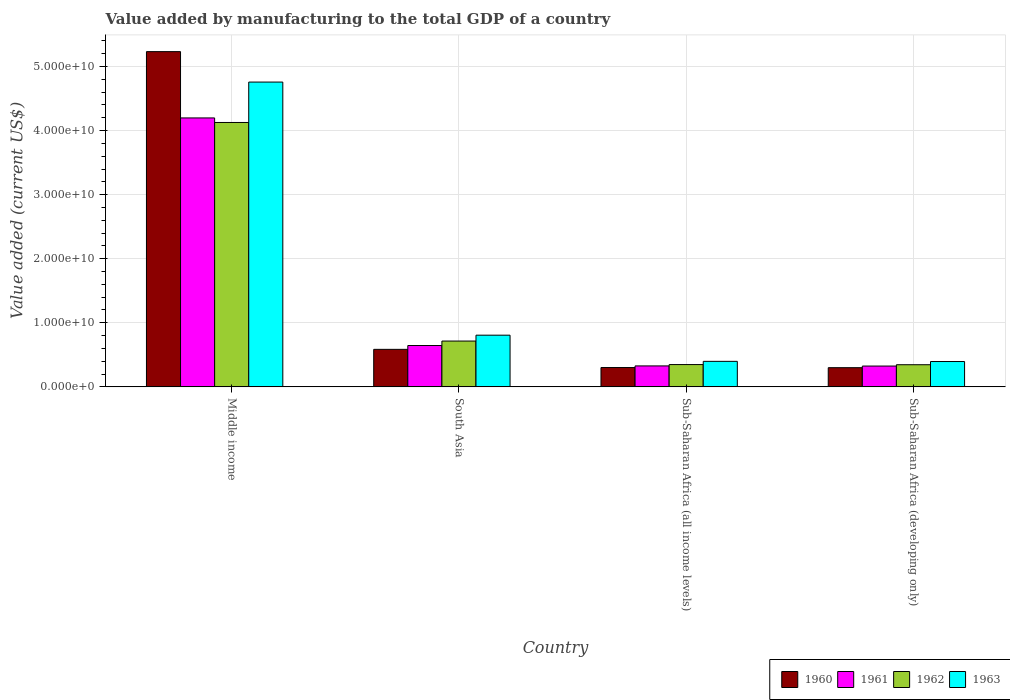Are the number of bars per tick equal to the number of legend labels?
Your answer should be compact. Yes. How many bars are there on the 4th tick from the left?
Give a very brief answer. 4. How many bars are there on the 3rd tick from the right?
Give a very brief answer. 4. What is the label of the 3rd group of bars from the left?
Provide a succinct answer. Sub-Saharan Africa (all income levels). In how many cases, is the number of bars for a given country not equal to the number of legend labels?
Your response must be concise. 0. What is the value added by manufacturing to the total GDP in 1960 in South Asia?
Offer a terse response. 5.86e+09. Across all countries, what is the maximum value added by manufacturing to the total GDP in 1963?
Your answer should be very brief. 4.76e+1. Across all countries, what is the minimum value added by manufacturing to the total GDP in 1963?
Offer a very short reply. 3.95e+09. In which country was the value added by manufacturing to the total GDP in 1963 minimum?
Offer a terse response. Sub-Saharan Africa (developing only). What is the total value added by manufacturing to the total GDP in 1961 in the graph?
Ensure brevity in your answer.  5.49e+1. What is the difference between the value added by manufacturing to the total GDP in 1961 in South Asia and that in Sub-Saharan Africa (all income levels)?
Keep it short and to the point. 3.18e+09. What is the difference between the value added by manufacturing to the total GDP in 1961 in South Asia and the value added by manufacturing to the total GDP in 1962 in Sub-Saharan Africa (all income levels)?
Your answer should be compact. 2.97e+09. What is the average value added by manufacturing to the total GDP in 1961 per country?
Offer a very short reply. 1.37e+1. What is the difference between the value added by manufacturing to the total GDP of/in 1963 and value added by manufacturing to the total GDP of/in 1961 in South Asia?
Your answer should be compact. 1.61e+09. In how many countries, is the value added by manufacturing to the total GDP in 1962 greater than 46000000000 US$?
Ensure brevity in your answer.  0. What is the ratio of the value added by manufacturing to the total GDP in 1962 in Sub-Saharan Africa (all income levels) to that in Sub-Saharan Africa (developing only)?
Offer a very short reply. 1.01. Is the value added by manufacturing to the total GDP in 1960 in Sub-Saharan Africa (all income levels) less than that in Sub-Saharan Africa (developing only)?
Ensure brevity in your answer.  No. Is the difference between the value added by manufacturing to the total GDP in 1963 in Sub-Saharan Africa (all income levels) and Sub-Saharan Africa (developing only) greater than the difference between the value added by manufacturing to the total GDP in 1961 in Sub-Saharan Africa (all income levels) and Sub-Saharan Africa (developing only)?
Your answer should be very brief. Yes. What is the difference between the highest and the second highest value added by manufacturing to the total GDP in 1960?
Provide a succinct answer. 2.84e+09. What is the difference between the highest and the lowest value added by manufacturing to the total GDP in 1963?
Keep it short and to the point. 4.36e+1. Is it the case that in every country, the sum of the value added by manufacturing to the total GDP in 1962 and value added by manufacturing to the total GDP in 1963 is greater than the sum of value added by manufacturing to the total GDP in 1961 and value added by manufacturing to the total GDP in 1960?
Your answer should be very brief. Yes. What does the 4th bar from the left in Sub-Saharan Africa (all income levels) represents?
Provide a succinct answer. 1963. What does the 3rd bar from the right in Sub-Saharan Africa (all income levels) represents?
Keep it short and to the point. 1961. How many bars are there?
Ensure brevity in your answer.  16. Are all the bars in the graph horizontal?
Offer a very short reply. No. How are the legend labels stacked?
Your answer should be very brief. Horizontal. What is the title of the graph?
Keep it short and to the point. Value added by manufacturing to the total GDP of a country. Does "1961" appear as one of the legend labels in the graph?
Your response must be concise. Yes. What is the label or title of the Y-axis?
Make the answer very short. Value added (current US$). What is the Value added (current US$) of 1960 in Middle income?
Your response must be concise. 5.23e+1. What is the Value added (current US$) of 1961 in Middle income?
Your answer should be compact. 4.20e+1. What is the Value added (current US$) in 1962 in Middle income?
Keep it short and to the point. 4.13e+1. What is the Value added (current US$) of 1963 in Middle income?
Keep it short and to the point. 4.76e+1. What is the Value added (current US$) in 1960 in South Asia?
Make the answer very short. 5.86e+09. What is the Value added (current US$) of 1961 in South Asia?
Give a very brief answer. 6.45e+09. What is the Value added (current US$) of 1962 in South Asia?
Offer a very short reply. 7.15e+09. What is the Value added (current US$) of 1963 in South Asia?
Your answer should be compact. 8.07e+09. What is the Value added (current US$) in 1960 in Sub-Saharan Africa (all income levels)?
Your answer should be very brief. 3.02e+09. What is the Value added (current US$) of 1961 in Sub-Saharan Africa (all income levels)?
Your answer should be compact. 3.27e+09. What is the Value added (current US$) in 1962 in Sub-Saharan Africa (all income levels)?
Make the answer very short. 3.48e+09. What is the Value added (current US$) of 1963 in Sub-Saharan Africa (all income levels)?
Offer a very short reply. 3.98e+09. What is the Value added (current US$) in 1960 in Sub-Saharan Africa (developing only)?
Provide a succinct answer. 2.99e+09. What is the Value added (current US$) of 1961 in Sub-Saharan Africa (developing only)?
Your response must be concise. 3.25e+09. What is the Value added (current US$) in 1962 in Sub-Saharan Africa (developing only)?
Your answer should be compact. 3.46e+09. What is the Value added (current US$) in 1963 in Sub-Saharan Africa (developing only)?
Your response must be concise. 3.95e+09. Across all countries, what is the maximum Value added (current US$) of 1960?
Your answer should be very brief. 5.23e+1. Across all countries, what is the maximum Value added (current US$) in 1961?
Your answer should be very brief. 4.20e+1. Across all countries, what is the maximum Value added (current US$) in 1962?
Ensure brevity in your answer.  4.13e+1. Across all countries, what is the maximum Value added (current US$) in 1963?
Provide a succinct answer. 4.76e+1. Across all countries, what is the minimum Value added (current US$) in 1960?
Provide a succinct answer. 2.99e+09. Across all countries, what is the minimum Value added (current US$) of 1961?
Provide a succinct answer. 3.25e+09. Across all countries, what is the minimum Value added (current US$) of 1962?
Provide a succinct answer. 3.46e+09. Across all countries, what is the minimum Value added (current US$) of 1963?
Ensure brevity in your answer.  3.95e+09. What is the total Value added (current US$) in 1960 in the graph?
Keep it short and to the point. 6.42e+1. What is the total Value added (current US$) of 1961 in the graph?
Keep it short and to the point. 5.49e+1. What is the total Value added (current US$) in 1962 in the graph?
Your response must be concise. 5.53e+1. What is the total Value added (current US$) of 1963 in the graph?
Your answer should be very brief. 6.36e+1. What is the difference between the Value added (current US$) in 1960 in Middle income and that in South Asia?
Make the answer very short. 4.65e+1. What is the difference between the Value added (current US$) of 1961 in Middle income and that in South Asia?
Offer a very short reply. 3.55e+1. What is the difference between the Value added (current US$) of 1962 in Middle income and that in South Asia?
Give a very brief answer. 3.41e+1. What is the difference between the Value added (current US$) in 1963 in Middle income and that in South Asia?
Your answer should be compact. 3.95e+1. What is the difference between the Value added (current US$) in 1960 in Middle income and that in Sub-Saharan Africa (all income levels)?
Ensure brevity in your answer.  4.93e+1. What is the difference between the Value added (current US$) of 1961 in Middle income and that in Sub-Saharan Africa (all income levels)?
Offer a terse response. 3.87e+1. What is the difference between the Value added (current US$) of 1962 in Middle income and that in Sub-Saharan Africa (all income levels)?
Ensure brevity in your answer.  3.78e+1. What is the difference between the Value added (current US$) in 1963 in Middle income and that in Sub-Saharan Africa (all income levels)?
Offer a terse response. 4.36e+1. What is the difference between the Value added (current US$) in 1960 in Middle income and that in Sub-Saharan Africa (developing only)?
Offer a very short reply. 4.93e+1. What is the difference between the Value added (current US$) in 1961 in Middle income and that in Sub-Saharan Africa (developing only)?
Your answer should be compact. 3.87e+1. What is the difference between the Value added (current US$) in 1962 in Middle income and that in Sub-Saharan Africa (developing only)?
Give a very brief answer. 3.78e+1. What is the difference between the Value added (current US$) in 1963 in Middle income and that in Sub-Saharan Africa (developing only)?
Offer a terse response. 4.36e+1. What is the difference between the Value added (current US$) in 1960 in South Asia and that in Sub-Saharan Africa (all income levels)?
Provide a succinct answer. 2.84e+09. What is the difference between the Value added (current US$) in 1961 in South Asia and that in Sub-Saharan Africa (all income levels)?
Provide a short and direct response. 3.18e+09. What is the difference between the Value added (current US$) of 1962 in South Asia and that in Sub-Saharan Africa (all income levels)?
Offer a terse response. 3.67e+09. What is the difference between the Value added (current US$) of 1963 in South Asia and that in Sub-Saharan Africa (all income levels)?
Make the answer very short. 4.08e+09. What is the difference between the Value added (current US$) of 1960 in South Asia and that in Sub-Saharan Africa (developing only)?
Offer a terse response. 2.86e+09. What is the difference between the Value added (current US$) in 1961 in South Asia and that in Sub-Saharan Africa (developing only)?
Your answer should be very brief. 3.21e+09. What is the difference between the Value added (current US$) in 1962 in South Asia and that in Sub-Saharan Africa (developing only)?
Keep it short and to the point. 3.70e+09. What is the difference between the Value added (current US$) in 1963 in South Asia and that in Sub-Saharan Africa (developing only)?
Offer a terse response. 4.11e+09. What is the difference between the Value added (current US$) of 1960 in Sub-Saharan Africa (all income levels) and that in Sub-Saharan Africa (developing only)?
Give a very brief answer. 2.16e+07. What is the difference between the Value added (current US$) of 1961 in Sub-Saharan Africa (all income levels) and that in Sub-Saharan Africa (developing only)?
Your response must be concise. 2.34e+07. What is the difference between the Value added (current US$) in 1962 in Sub-Saharan Africa (all income levels) and that in Sub-Saharan Africa (developing only)?
Your answer should be compact. 2.49e+07. What is the difference between the Value added (current US$) in 1963 in Sub-Saharan Africa (all income levels) and that in Sub-Saharan Africa (developing only)?
Provide a succinct answer. 2.85e+07. What is the difference between the Value added (current US$) of 1960 in Middle income and the Value added (current US$) of 1961 in South Asia?
Offer a terse response. 4.59e+1. What is the difference between the Value added (current US$) of 1960 in Middle income and the Value added (current US$) of 1962 in South Asia?
Ensure brevity in your answer.  4.52e+1. What is the difference between the Value added (current US$) in 1960 in Middle income and the Value added (current US$) in 1963 in South Asia?
Your response must be concise. 4.42e+1. What is the difference between the Value added (current US$) of 1961 in Middle income and the Value added (current US$) of 1962 in South Asia?
Provide a short and direct response. 3.48e+1. What is the difference between the Value added (current US$) of 1961 in Middle income and the Value added (current US$) of 1963 in South Asia?
Ensure brevity in your answer.  3.39e+1. What is the difference between the Value added (current US$) of 1962 in Middle income and the Value added (current US$) of 1963 in South Asia?
Provide a succinct answer. 3.32e+1. What is the difference between the Value added (current US$) in 1960 in Middle income and the Value added (current US$) in 1961 in Sub-Saharan Africa (all income levels)?
Ensure brevity in your answer.  4.90e+1. What is the difference between the Value added (current US$) of 1960 in Middle income and the Value added (current US$) of 1962 in Sub-Saharan Africa (all income levels)?
Make the answer very short. 4.88e+1. What is the difference between the Value added (current US$) in 1960 in Middle income and the Value added (current US$) in 1963 in Sub-Saharan Africa (all income levels)?
Ensure brevity in your answer.  4.83e+1. What is the difference between the Value added (current US$) in 1961 in Middle income and the Value added (current US$) in 1962 in Sub-Saharan Africa (all income levels)?
Your answer should be very brief. 3.85e+1. What is the difference between the Value added (current US$) of 1961 in Middle income and the Value added (current US$) of 1963 in Sub-Saharan Africa (all income levels)?
Your response must be concise. 3.80e+1. What is the difference between the Value added (current US$) of 1962 in Middle income and the Value added (current US$) of 1963 in Sub-Saharan Africa (all income levels)?
Ensure brevity in your answer.  3.73e+1. What is the difference between the Value added (current US$) in 1960 in Middle income and the Value added (current US$) in 1961 in Sub-Saharan Africa (developing only)?
Ensure brevity in your answer.  4.91e+1. What is the difference between the Value added (current US$) in 1960 in Middle income and the Value added (current US$) in 1962 in Sub-Saharan Africa (developing only)?
Provide a short and direct response. 4.89e+1. What is the difference between the Value added (current US$) in 1960 in Middle income and the Value added (current US$) in 1963 in Sub-Saharan Africa (developing only)?
Make the answer very short. 4.84e+1. What is the difference between the Value added (current US$) in 1961 in Middle income and the Value added (current US$) in 1962 in Sub-Saharan Africa (developing only)?
Provide a succinct answer. 3.85e+1. What is the difference between the Value added (current US$) of 1961 in Middle income and the Value added (current US$) of 1963 in Sub-Saharan Africa (developing only)?
Make the answer very short. 3.80e+1. What is the difference between the Value added (current US$) of 1962 in Middle income and the Value added (current US$) of 1963 in Sub-Saharan Africa (developing only)?
Provide a short and direct response. 3.73e+1. What is the difference between the Value added (current US$) in 1960 in South Asia and the Value added (current US$) in 1961 in Sub-Saharan Africa (all income levels)?
Your answer should be compact. 2.58e+09. What is the difference between the Value added (current US$) in 1960 in South Asia and the Value added (current US$) in 1962 in Sub-Saharan Africa (all income levels)?
Your answer should be very brief. 2.37e+09. What is the difference between the Value added (current US$) in 1960 in South Asia and the Value added (current US$) in 1963 in Sub-Saharan Africa (all income levels)?
Offer a very short reply. 1.87e+09. What is the difference between the Value added (current US$) of 1961 in South Asia and the Value added (current US$) of 1962 in Sub-Saharan Africa (all income levels)?
Ensure brevity in your answer.  2.97e+09. What is the difference between the Value added (current US$) of 1961 in South Asia and the Value added (current US$) of 1963 in Sub-Saharan Africa (all income levels)?
Offer a very short reply. 2.47e+09. What is the difference between the Value added (current US$) in 1962 in South Asia and the Value added (current US$) in 1963 in Sub-Saharan Africa (all income levels)?
Keep it short and to the point. 3.17e+09. What is the difference between the Value added (current US$) of 1960 in South Asia and the Value added (current US$) of 1961 in Sub-Saharan Africa (developing only)?
Give a very brief answer. 2.61e+09. What is the difference between the Value added (current US$) of 1960 in South Asia and the Value added (current US$) of 1962 in Sub-Saharan Africa (developing only)?
Offer a terse response. 2.40e+09. What is the difference between the Value added (current US$) in 1960 in South Asia and the Value added (current US$) in 1963 in Sub-Saharan Africa (developing only)?
Your answer should be very brief. 1.90e+09. What is the difference between the Value added (current US$) in 1961 in South Asia and the Value added (current US$) in 1962 in Sub-Saharan Africa (developing only)?
Your response must be concise. 3.00e+09. What is the difference between the Value added (current US$) of 1961 in South Asia and the Value added (current US$) of 1963 in Sub-Saharan Africa (developing only)?
Your response must be concise. 2.50e+09. What is the difference between the Value added (current US$) of 1962 in South Asia and the Value added (current US$) of 1963 in Sub-Saharan Africa (developing only)?
Provide a succinct answer. 3.20e+09. What is the difference between the Value added (current US$) of 1960 in Sub-Saharan Africa (all income levels) and the Value added (current US$) of 1961 in Sub-Saharan Africa (developing only)?
Make the answer very short. -2.32e+08. What is the difference between the Value added (current US$) of 1960 in Sub-Saharan Africa (all income levels) and the Value added (current US$) of 1962 in Sub-Saharan Africa (developing only)?
Your answer should be very brief. -4.40e+08. What is the difference between the Value added (current US$) of 1960 in Sub-Saharan Africa (all income levels) and the Value added (current US$) of 1963 in Sub-Saharan Africa (developing only)?
Offer a terse response. -9.39e+08. What is the difference between the Value added (current US$) in 1961 in Sub-Saharan Africa (all income levels) and the Value added (current US$) in 1962 in Sub-Saharan Africa (developing only)?
Provide a short and direct response. -1.85e+08. What is the difference between the Value added (current US$) of 1961 in Sub-Saharan Africa (all income levels) and the Value added (current US$) of 1963 in Sub-Saharan Africa (developing only)?
Provide a succinct answer. -6.84e+08. What is the difference between the Value added (current US$) in 1962 in Sub-Saharan Africa (all income levels) and the Value added (current US$) in 1963 in Sub-Saharan Africa (developing only)?
Your answer should be very brief. -4.74e+08. What is the average Value added (current US$) in 1960 per country?
Give a very brief answer. 1.60e+1. What is the average Value added (current US$) in 1961 per country?
Your answer should be compact. 1.37e+1. What is the average Value added (current US$) of 1962 per country?
Give a very brief answer. 1.38e+1. What is the average Value added (current US$) in 1963 per country?
Provide a succinct answer. 1.59e+1. What is the difference between the Value added (current US$) of 1960 and Value added (current US$) of 1961 in Middle income?
Keep it short and to the point. 1.03e+1. What is the difference between the Value added (current US$) in 1960 and Value added (current US$) in 1962 in Middle income?
Your answer should be very brief. 1.11e+1. What is the difference between the Value added (current US$) in 1960 and Value added (current US$) in 1963 in Middle income?
Make the answer very short. 4.75e+09. What is the difference between the Value added (current US$) of 1961 and Value added (current US$) of 1962 in Middle income?
Provide a short and direct response. 7.12e+08. What is the difference between the Value added (current US$) of 1961 and Value added (current US$) of 1963 in Middle income?
Your answer should be compact. -5.59e+09. What is the difference between the Value added (current US$) in 1962 and Value added (current US$) in 1963 in Middle income?
Offer a very short reply. -6.31e+09. What is the difference between the Value added (current US$) in 1960 and Value added (current US$) in 1961 in South Asia?
Offer a very short reply. -5.98e+08. What is the difference between the Value added (current US$) of 1960 and Value added (current US$) of 1962 in South Asia?
Make the answer very short. -1.30e+09. What is the difference between the Value added (current US$) of 1960 and Value added (current US$) of 1963 in South Asia?
Offer a terse response. -2.21e+09. What is the difference between the Value added (current US$) in 1961 and Value added (current US$) in 1962 in South Asia?
Offer a terse response. -6.98e+08. What is the difference between the Value added (current US$) in 1961 and Value added (current US$) in 1963 in South Asia?
Offer a terse response. -1.61e+09. What is the difference between the Value added (current US$) of 1962 and Value added (current US$) of 1963 in South Asia?
Your response must be concise. -9.17e+08. What is the difference between the Value added (current US$) of 1960 and Value added (current US$) of 1961 in Sub-Saharan Africa (all income levels)?
Your answer should be very brief. -2.55e+08. What is the difference between the Value added (current US$) of 1960 and Value added (current US$) of 1962 in Sub-Saharan Africa (all income levels)?
Give a very brief answer. -4.65e+08. What is the difference between the Value added (current US$) in 1960 and Value added (current US$) in 1963 in Sub-Saharan Africa (all income levels)?
Ensure brevity in your answer.  -9.68e+08. What is the difference between the Value added (current US$) of 1961 and Value added (current US$) of 1962 in Sub-Saharan Africa (all income levels)?
Offer a terse response. -2.09e+08. What is the difference between the Value added (current US$) of 1961 and Value added (current US$) of 1963 in Sub-Saharan Africa (all income levels)?
Ensure brevity in your answer.  -7.12e+08. What is the difference between the Value added (current US$) of 1962 and Value added (current US$) of 1963 in Sub-Saharan Africa (all income levels)?
Your answer should be very brief. -5.03e+08. What is the difference between the Value added (current US$) in 1960 and Value added (current US$) in 1961 in Sub-Saharan Africa (developing only)?
Your response must be concise. -2.54e+08. What is the difference between the Value added (current US$) of 1960 and Value added (current US$) of 1962 in Sub-Saharan Africa (developing only)?
Your response must be concise. -4.61e+08. What is the difference between the Value added (current US$) of 1960 and Value added (current US$) of 1963 in Sub-Saharan Africa (developing only)?
Provide a succinct answer. -9.61e+08. What is the difference between the Value added (current US$) in 1961 and Value added (current US$) in 1962 in Sub-Saharan Africa (developing only)?
Make the answer very short. -2.08e+08. What is the difference between the Value added (current US$) of 1961 and Value added (current US$) of 1963 in Sub-Saharan Africa (developing only)?
Keep it short and to the point. -7.07e+08. What is the difference between the Value added (current US$) of 1962 and Value added (current US$) of 1963 in Sub-Saharan Africa (developing only)?
Provide a succinct answer. -4.99e+08. What is the ratio of the Value added (current US$) of 1960 in Middle income to that in South Asia?
Ensure brevity in your answer.  8.93. What is the ratio of the Value added (current US$) in 1961 in Middle income to that in South Asia?
Make the answer very short. 6.5. What is the ratio of the Value added (current US$) of 1962 in Middle income to that in South Asia?
Provide a succinct answer. 5.77. What is the ratio of the Value added (current US$) of 1963 in Middle income to that in South Asia?
Your answer should be very brief. 5.9. What is the ratio of the Value added (current US$) in 1960 in Middle income to that in Sub-Saharan Africa (all income levels)?
Make the answer very short. 17.35. What is the ratio of the Value added (current US$) in 1961 in Middle income to that in Sub-Saharan Africa (all income levels)?
Your response must be concise. 12.83. What is the ratio of the Value added (current US$) in 1962 in Middle income to that in Sub-Saharan Africa (all income levels)?
Give a very brief answer. 11.85. What is the ratio of the Value added (current US$) of 1963 in Middle income to that in Sub-Saharan Africa (all income levels)?
Your answer should be very brief. 11.94. What is the ratio of the Value added (current US$) in 1960 in Middle income to that in Sub-Saharan Africa (developing only)?
Make the answer very short. 17.47. What is the ratio of the Value added (current US$) of 1961 in Middle income to that in Sub-Saharan Africa (developing only)?
Give a very brief answer. 12.92. What is the ratio of the Value added (current US$) in 1962 in Middle income to that in Sub-Saharan Africa (developing only)?
Offer a very short reply. 11.94. What is the ratio of the Value added (current US$) in 1963 in Middle income to that in Sub-Saharan Africa (developing only)?
Your response must be concise. 12.03. What is the ratio of the Value added (current US$) in 1960 in South Asia to that in Sub-Saharan Africa (all income levels)?
Keep it short and to the point. 1.94. What is the ratio of the Value added (current US$) of 1961 in South Asia to that in Sub-Saharan Africa (all income levels)?
Your answer should be very brief. 1.97. What is the ratio of the Value added (current US$) in 1962 in South Asia to that in Sub-Saharan Africa (all income levels)?
Ensure brevity in your answer.  2.05. What is the ratio of the Value added (current US$) in 1963 in South Asia to that in Sub-Saharan Africa (all income levels)?
Give a very brief answer. 2.03. What is the ratio of the Value added (current US$) in 1960 in South Asia to that in Sub-Saharan Africa (developing only)?
Provide a short and direct response. 1.96. What is the ratio of the Value added (current US$) in 1961 in South Asia to that in Sub-Saharan Africa (developing only)?
Your response must be concise. 1.99. What is the ratio of the Value added (current US$) in 1962 in South Asia to that in Sub-Saharan Africa (developing only)?
Keep it short and to the point. 2.07. What is the ratio of the Value added (current US$) in 1963 in South Asia to that in Sub-Saharan Africa (developing only)?
Provide a succinct answer. 2.04. What is the ratio of the Value added (current US$) in 1960 in Sub-Saharan Africa (all income levels) to that in Sub-Saharan Africa (developing only)?
Keep it short and to the point. 1.01. What is the ratio of the Value added (current US$) of 1963 in Sub-Saharan Africa (all income levels) to that in Sub-Saharan Africa (developing only)?
Make the answer very short. 1.01. What is the difference between the highest and the second highest Value added (current US$) in 1960?
Offer a terse response. 4.65e+1. What is the difference between the highest and the second highest Value added (current US$) of 1961?
Offer a very short reply. 3.55e+1. What is the difference between the highest and the second highest Value added (current US$) of 1962?
Provide a succinct answer. 3.41e+1. What is the difference between the highest and the second highest Value added (current US$) in 1963?
Your answer should be very brief. 3.95e+1. What is the difference between the highest and the lowest Value added (current US$) in 1960?
Your response must be concise. 4.93e+1. What is the difference between the highest and the lowest Value added (current US$) of 1961?
Provide a succinct answer. 3.87e+1. What is the difference between the highest and the lowest Value added (current US$) in 1962?
Keep it short and to the point. 3.78e+1. What is the difference between the highest and the lowest Value added (current US$) of 1963?
Your response must be concise. 4.36e+1. 